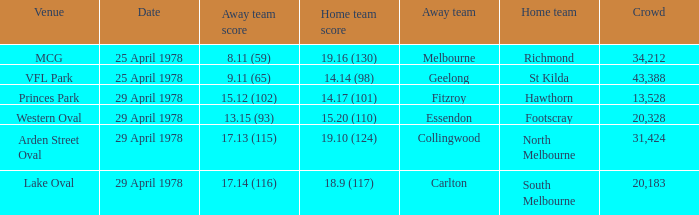In what venue was the hosted away team Essendon? Western Oval. 